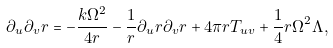<formula> <loc_0><loc_0><loc_500><loc_500>\partial _ { u } \partial _ { v } r = - \frac { k \Omega ^ { 2 } } { 4 r } - \frac { 1 } { r } \partial _ { u } r \partial _ { v } r + 4 \pi r T _ { u v } + \frac { 1 } { 4 } r \Omega ^ { 2 } \Lambda ,</formula> 